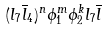Convert formula to latex. <formula><loc_0><loc_0><loc_500><loc_500>( l _ { 7 } { \overline { l } } _ { 4 } ) ^ { n } \phi _ { 1 } ^ { m } \phi _ { 2 } ^ { k } l _ { 7 } { \overline { l } }</formula> 